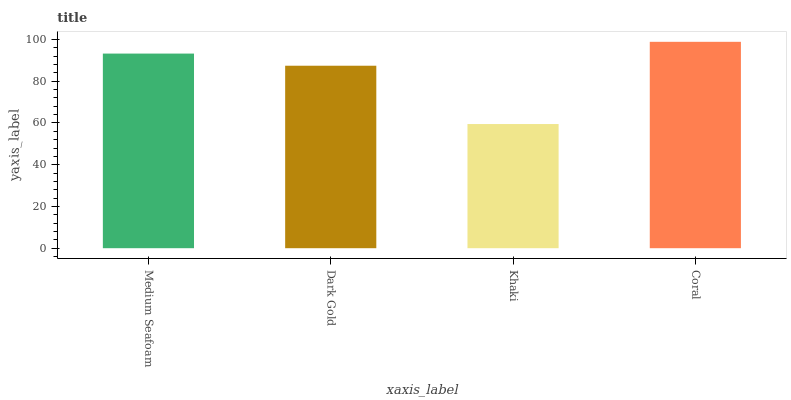Is Khaki the minimum?
Answer yes or no. Yes. Is Coral the maximum?
Answer yes or no. Yes. Is Dark Gold the minimum?
Answer yes or no. No. Is Dark Gold the maximum?
Answer yes or no. No. Is Medium Seafoam greater than Dark Gold?
Answer yes or no. Yes. Is Dark Gold less than Medium Seafoam?
Answer yes or no. Yes. Is Dark Gold greater than Medium Seafoam?
Answer yes or no. No. Is Medium Seafoam less than Dark Gold?
Answer yes or no. No. Is Medium Seafoam the high median?
Answer yes or no. Yes. Is Dark Gold the low median?
Answer yes or no. Yes. Is Dark Gold the high median?
Answer yes or no. No. Is Coral the low median?
Answer yes or no. No. 